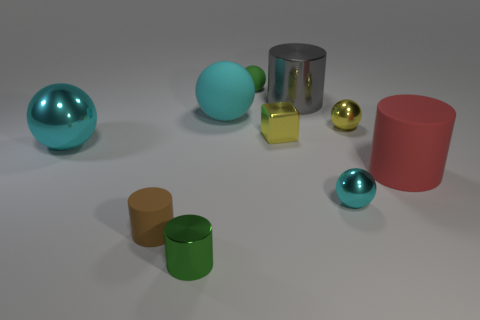Does the brown thing have the same shape as the big thing that is to the left of the big cyan matte thing?
Provide a short and direct response. No. Are there any other things that have the same size as the red thing?
Your response must be concise. Yes. What size is the green matte object that is the same shape as the large cyan shiny thing?
Your response must be concise. Small. Is the number of small green metal objects greater than the number of small purple things?
Your answer should be very brief. Yes. Do the large red thing and the big cyan matte thing have the same shape?
Your answer should be compact. No. There is a small green thing behind the rubber object that is in front of the large red object; what is its material?
Provide a succinct answer. Rubber. What material is the ball that is the same color as the tiny shiny cylinder?
Your answer should be compact. Rubber. Is the green metal thing the same size as the yellow metallic block?
Provide a short and direct response. Yes. Is there a red matte cylinder that is behind the small green object behind the red rubber cylinder?
Your answer should be compact. No. There is another metallic sphere that is the same color as the big metallic sphere; what is its size?
Ensure brevity in your answer.  Small. 